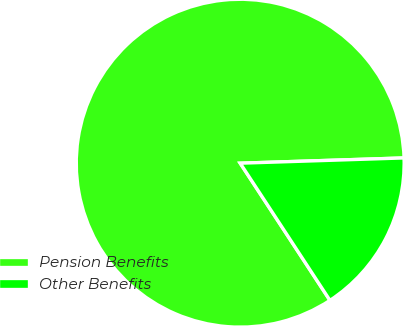Convert chart to OTSL. <chart><loc_0><loc_0><loc_500><loc_500><pie_chart><fcel>Pension Benefits<fcel>Other Benefits<nl><fcel>83.71%<fcel>16.29%<nl></chart> 